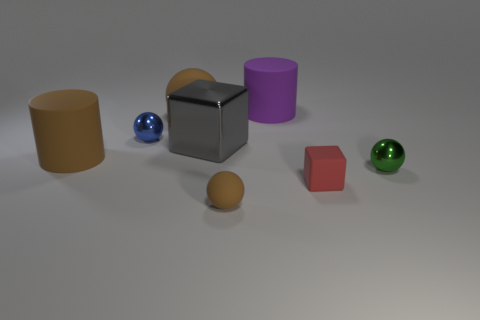Add 2 gray shiny things. How many objects exist? 10 Subtract all blocks. How many objects are left? 6 Subtract all red shiny objects. Subtract all small brown rubber balls. How many objects are left? 7 Add 6 big cubes. How many big cubes are left? 7 Add 2 big objects. How many big objects exist? 6 Subtract 0 green cylinders. How many objects are left? 8 